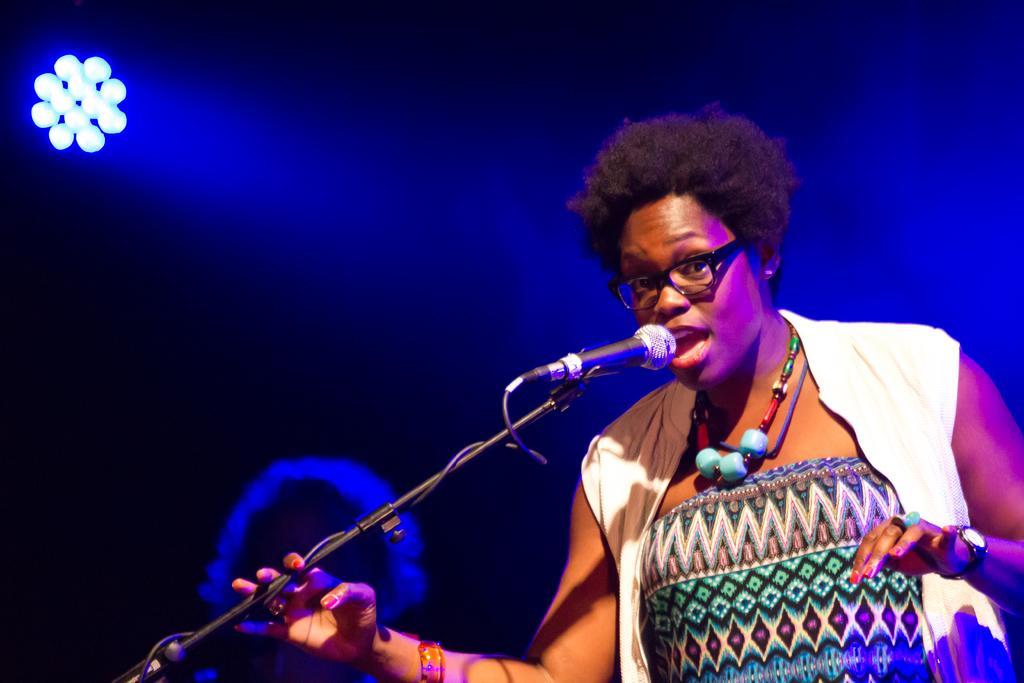In one or two sentences, can you explain what this image depicts? In this image we can see a person standing. There is a mic placed on the stand. In the background there are lights and we can see a person. 